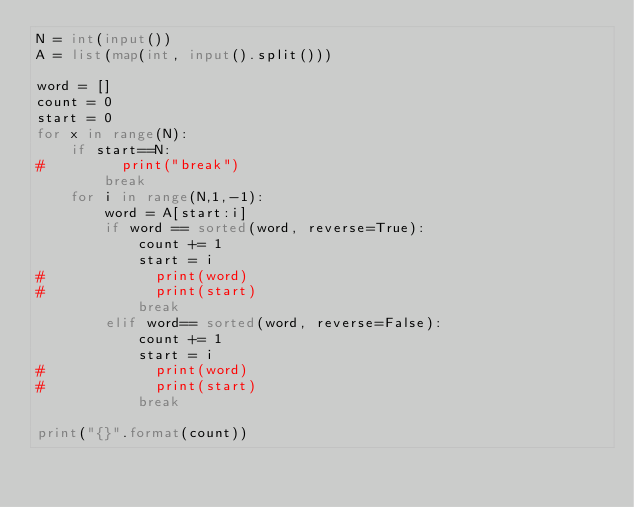<code> <loc_0><loc_0><loc_500><loc_500><_Python_>N = int(input())
A = list(map(int, input().split()))

word = []
count = 0
start = 0
for x in range(N):
    if start==N:
#         print("break")
        break
    for i in range(N,1,-1):
        word = A[start:i]
        if word == sorted(word, reverse=True):
            count += 1
            start = i
#             print(word)
#             print(start)
            break
        elif word== sorted(word, reverse=False):
            count += 1
            start = i
#             print(word)
#             print(start)
            break
            
print("{}".format(count))</code> 